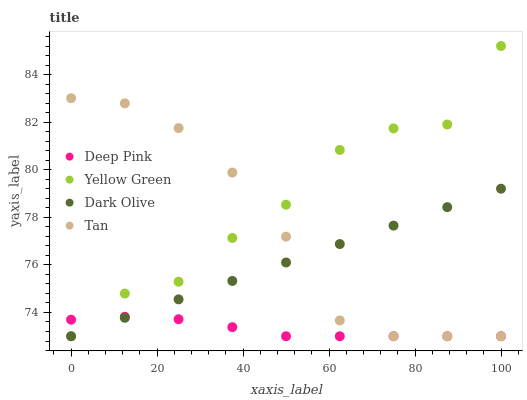Does Deep Pink have the minimum area under the curve?
Answer yes or no. Yes. Does Yellow Green have the maximum area under the curve?
Answer yes or no. Yes. Does Tan have the minimum area under the curve?
Answer yes or no. No. Does Tan have the maximum area under the curve?
Answer yes or no. No. Is Dark Olive the smoothest?
Answer yes or no. Yes. Is Yellow Green the roughest?
Answer yes or no. Yes. Is Tan the smoothest?
Answer yes or no. No. Is Tan the roughest?
Answer yes or no. No. Does Dark Olive have the lowest value?
Answer yes or no. Yes. Does Yellow Green have the highest value?
Answer yes or no. Yes. Does Tan have the highest value?
Answer yes or no. No. Does Dark Olive intersect Deep Pink?
Answer yes or no. Yes. Is Dark Olive less than Deep Pink?
Answer yes or no. No. Is Dark Olive greater than Deep Pink?
Answer yes or no. No. 